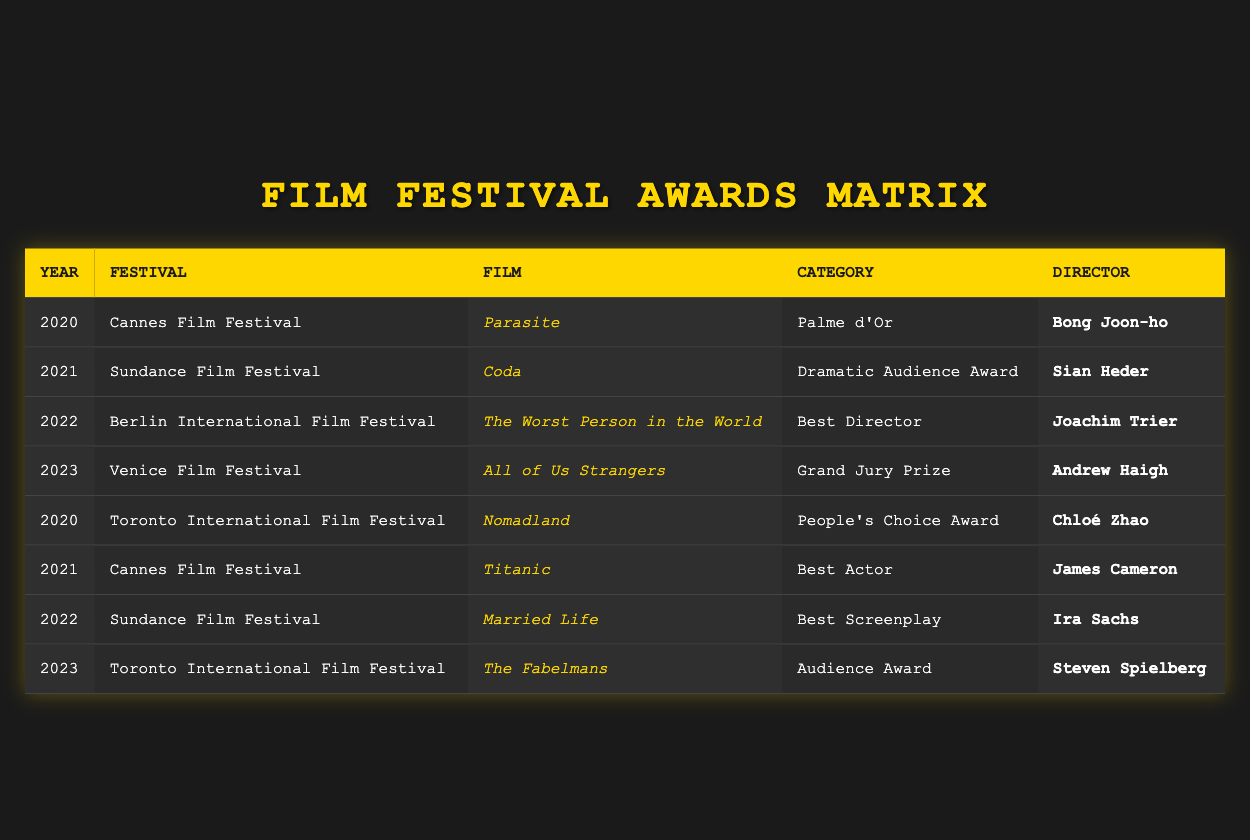What film won the Palme d'Or at the Cannes Film Festival in 2020? The table shows that "Parasite" won the Palme d'Or in 2020 at the Cannes Film Festival, as indicated in the relevant row.
Answer: Parasite Which director won the Best Director award at the Berlin International Film Festival in 2022? According to the table, Joachim Trier directed "The Worst Person in the World," which won Best Director at the Berlin International Film Festival in 2022.
Answer: Joachim Trier How many films won awards at the Cannes Film Festival over the years displayed? There are two films listed under the Cannes Film Festival: "Parasite" in 2020 and "Titanic" in 2021, indicating that two films won awards at this festival in the displayed years.
Answer: 2 Did any films win awards at both the Toronto International Film Festival and the Sundance Film Festival? The table shows that "Nomadland" won the People's Choice Award at the Toronto International Film Festival in 2020, and "Coda" won the Dramatic Audience Award at the Sundance Film Festival in 2021. However, they are different films at different festivals, so the answer is no.
Answer: No Which film won the Grand Jury Prize in 2023? By checking the table, it states that "All of Us Strangers" won the Grand Jury Prize at the Venice Film Festival in 2023, directly providing the necessary information.
Answer: All of Us Strangers What is the total number of different festivals represented in the table? The festivals listed in the table include the Cannes Film Festival, Sundance Film Festival, Berlin International Film Festival, and Toronto International Film Festival. In total, there are four different festivals represented.
Answer: 4 Which film won the Audience Award at the Toronto International Film Festival in 2023, and who was the director? The table indicates that "The Fabelmans" won the Audience Award at the Toronto International Film Festival in 2023, directed by Steven Spielberg, which combines information from both the film and director columns for that year.
Answer: The Fabelmans, Steven Spielberg How many awards were given out in the category of Best Screenplay according to the table? The category of Best Screenplay is mentioned once in the table, where "Married Life" won this award at the Sundance Film Festival in 2022. Hence, there is only one occurrence of this award in the data.
Answer: 1 